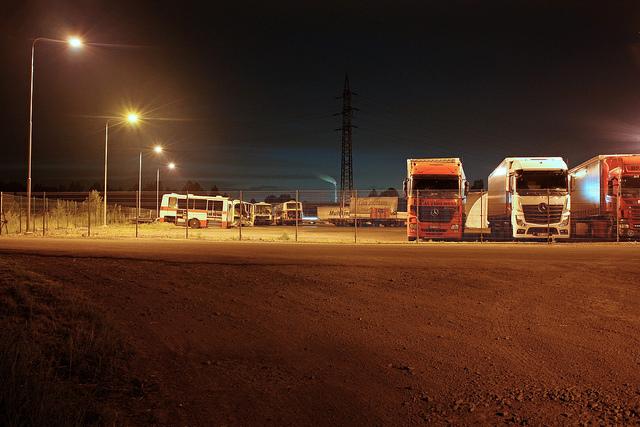How many trucks are there?
Concise answer only. 3. What color is the far right truck?
Short answer required. Red. How many street lamps are there?
Concise answer only. 4. 